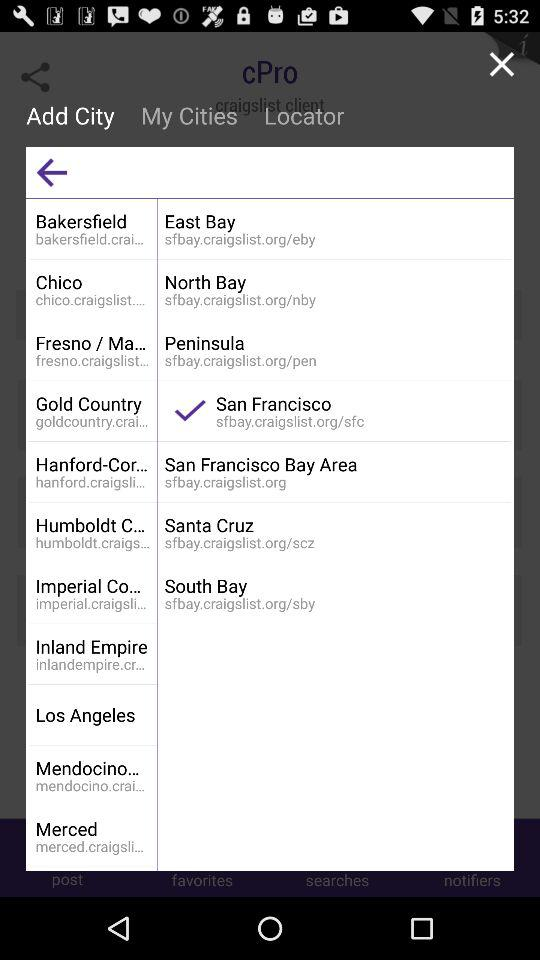What is the selected city? The selected city is San Francisco. 